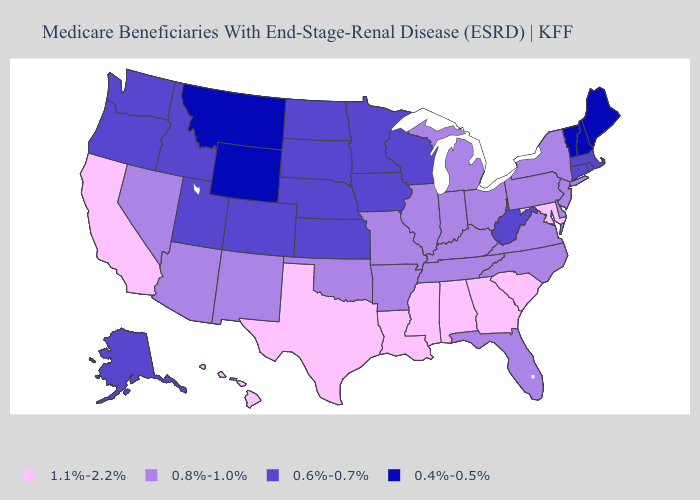Among the states that border New Jersey , which have the highest value?
Give a very brief answer. Delaware, New York, Pennsylvania. What is the lowest value in the Northeast?
Give a very brief answer. 0.4%-0.5%. Among the states that border Wyoming , does Montana have the highest value?
Answer briefly. No. Among the states that border South Carolina , does Georgia have the lowest value?
Short answer required. No. Which states hav the highest value in the Northeast?
Concise answer only. New Jersey, New York, Pennsylvania. Name the states that have a value in the range 0.6%-0.7%?
Be succinct. Alaska, Colorado, Connecticut, Idaho, Iowa, Kansas, Massachusetts, Minnesota, Nebraska, North Dakota, Oregon, Rhode Island, South Dakota, Utah, Washington, West Virginia, Wisconsin. What is the lowest value in the Northeast?
Be succinct. 0.4%-0.5%. Name the states that have a value in the range 0.6%-0.7%?
Answer briefly. Alaska, Colorado, Connecticut, Idaho, Iowa, Kansas, Massachusetts, Minnesota, Nebraska, North Dakota, Oregon, Rhode Island, South Dakota, Utah, Washington, West Virginia, Wisconsin. What is the lowest value in the Northeast?
Keep it brief. 0.4%-0.5%. Does the map have missing data?
Quick response, please. No. Among the states that border Connecticut , which have the highest value?
Be succinct. New York. Does the map have missing data?
Write a very short answer. No. What is the value of Alabama?
Give a very brief answer. 1.1%-2.2%. What is the highest value in the USA?
Give a very brief answer. 1.1%-2.2%. What is the lowest value in states that border Georgia?
Keep it brief. 0.8%-1.0%. 